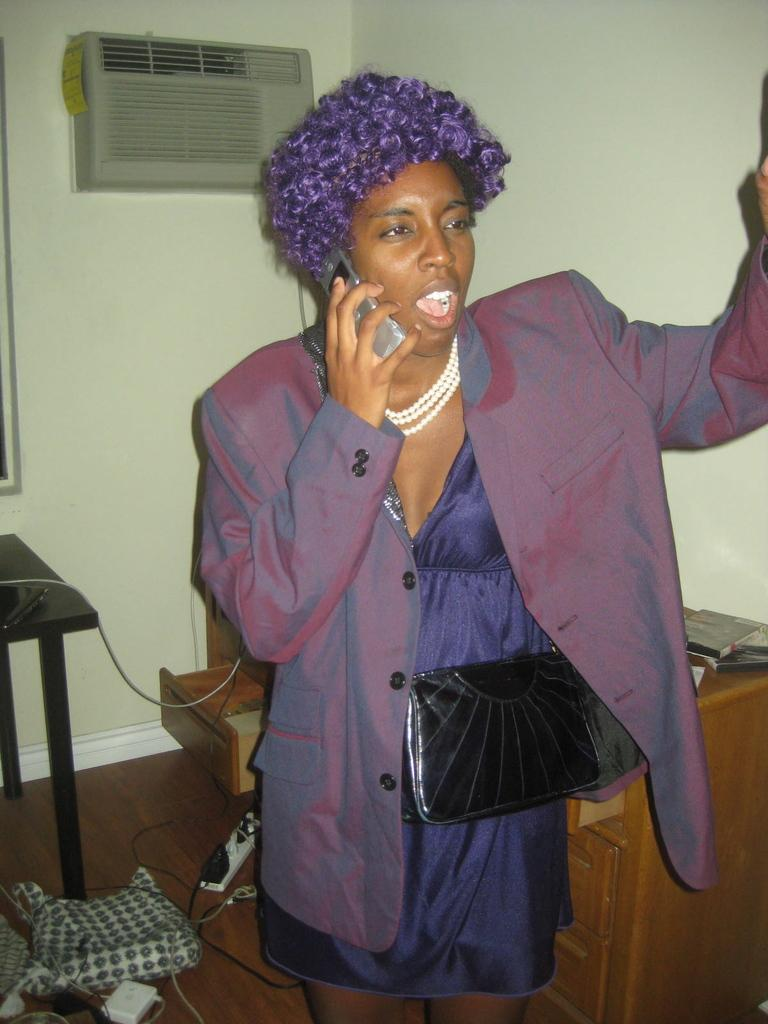Who is present in the image? There is a woman in the image. What is the woman wearing? The woman is wearing a purple dress. What is the woman doing in the image? The woman is speaking on a phone. What piece of furniture can be seen in the image? There is a table in the image. What type of product is visible in the background? There is a conditioner in the background of the image. What is the background setting of the image? There is a wall in the background of the image. What type of quilt is being used to express disgust in the image? There is no quilt or expression of disgust present in the image. What type of pan is being used to cook on the table in the image? There is no pan or cooking activity present in the image. 